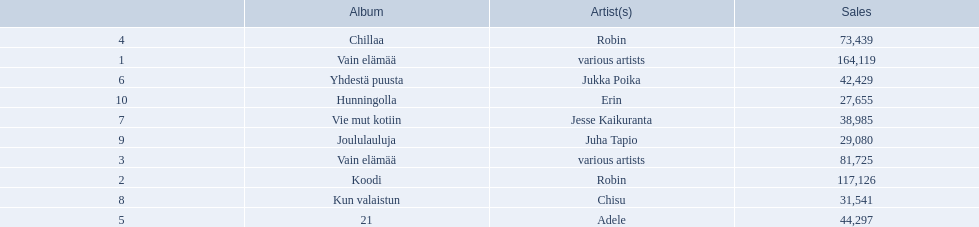Who is the artist for 21 album? Adele. Who is the artist for kun valaistun? Chisu. Which album had the same artist as chillaa? Koodi. 